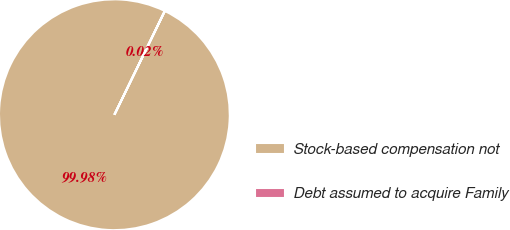Convert chart to OTSL. <chart><loc_0><loc_0><loc_500><loc_500><pie_chart><fcel>Stock-based compensation not<fcel>Debt assumed to acquire Family<nl><fcel>99.98%<fcel>0.02%<nl></chart> 